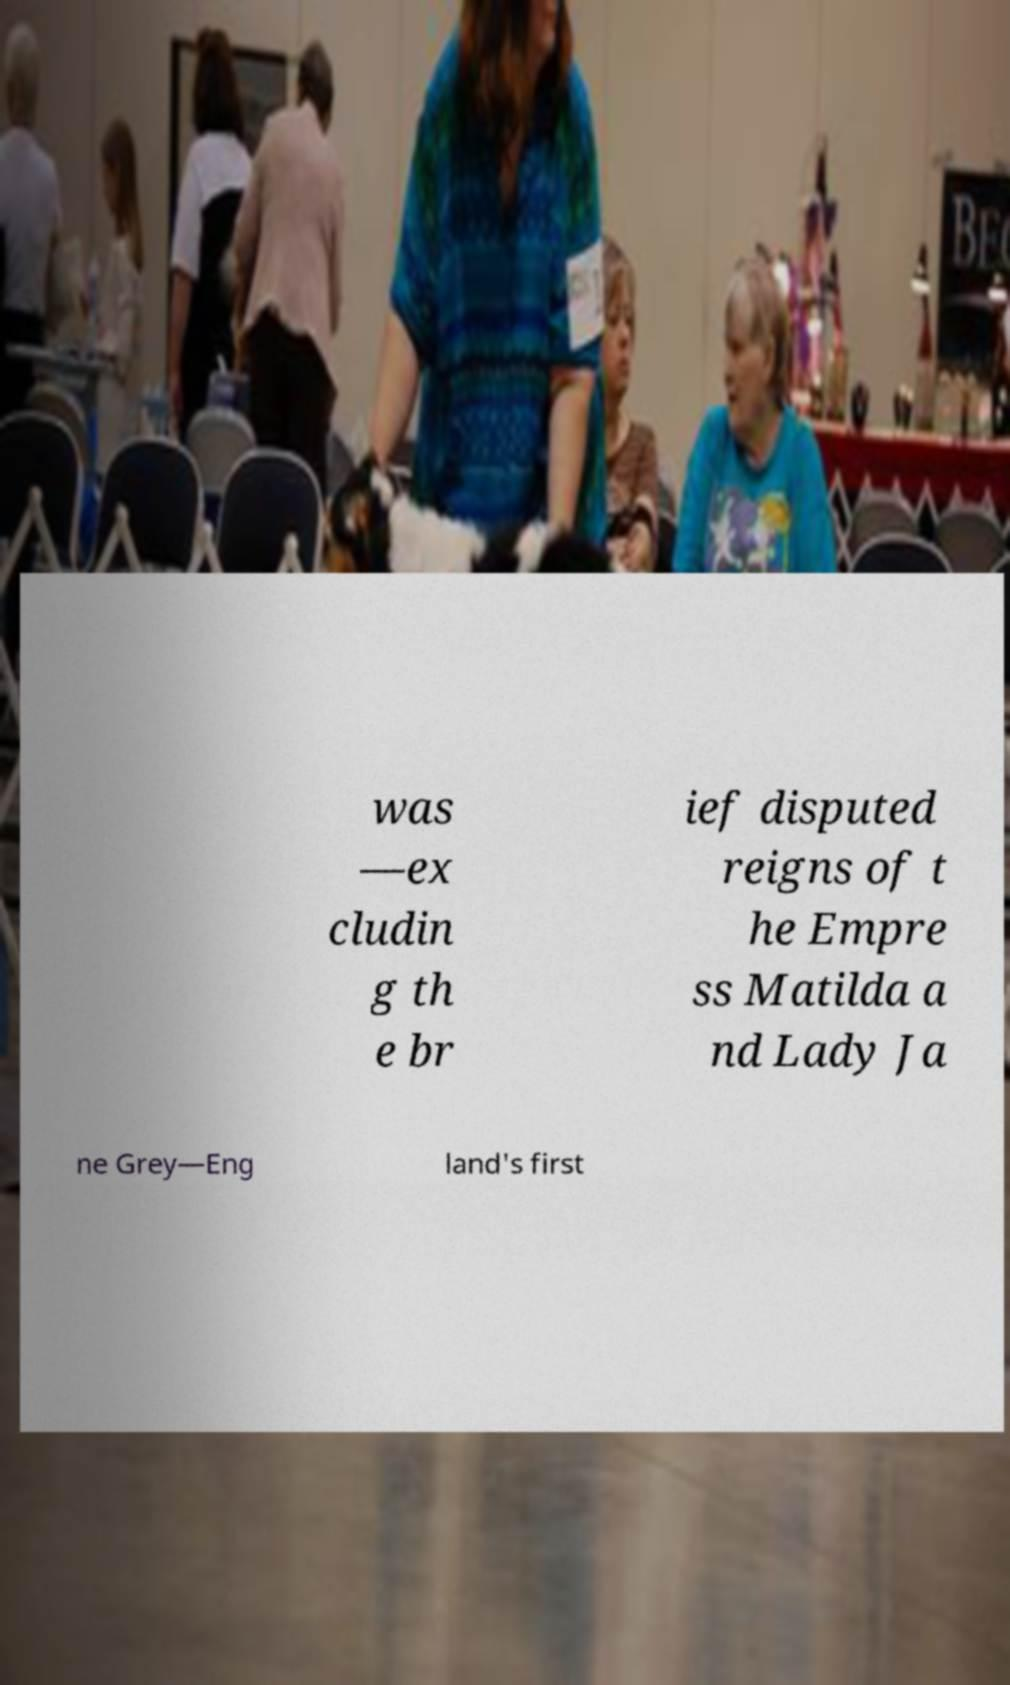Please identify and transcribe the text found in this image. was —ex cludin g th e br ief disputed reigns of t he Empre ss Matilda a nd Lady Ja ne Grey—Eng land's first 